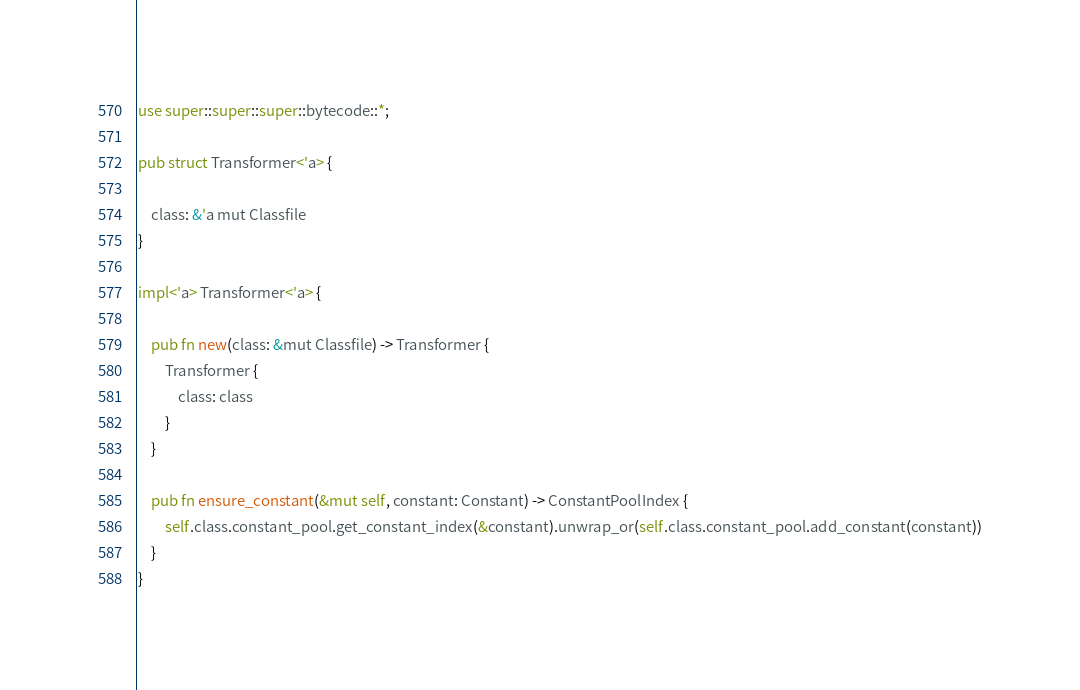Convert code to text. <code><loc_0><loc_0><loc_500><loc_500><_Rust_>use super::super::super::bytecode::*;

pub struct Transformer<'a> {

    class: &'a mut Classfile
}

impl<'a> Transformer<'a> {

    pub fn new(class: &mut Classfile) -> Transformer {
        Transformer {
            class: class
        }
    }

    pub fn ensure_constant(&mut self, constant: Constant) -> ConstantPoolIndex {
        self.class.constant_pool.get_constant_index(&constant).unwrap_or(self.class.constant_pool.add_constant(constant))
    }
}
</code> 